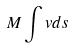<formula> <loc_0><loc_0><loc_500><loc_500>M \int v d s</formula> 